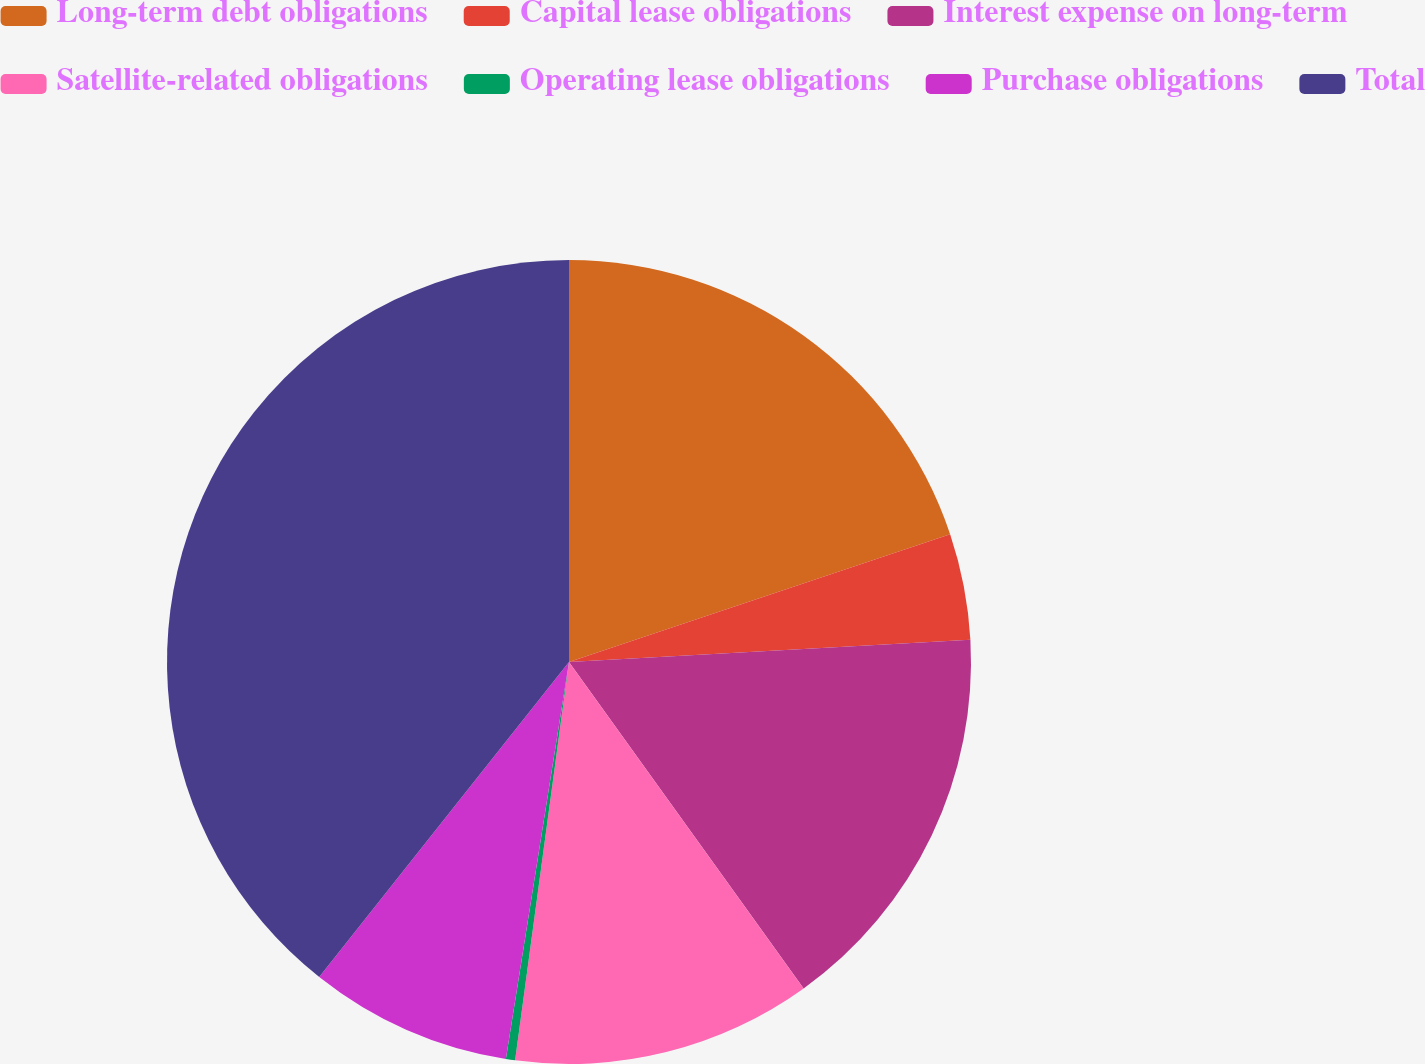<chart> <loc_0><loc_0><loc_500><loc_500><pie_chart><fcel>Long-term debt obligations<fcel>Capital lease obligations<fcel>Interest expense on long-term<fcel>Satellite-related obligations<fcel>Operating lease obligations<fcel>Purchase obligations<fcel>Total<nl><fcel>19.85%<fcel>4.27%<fcel>15.96%<fcel>12.06%<fcel>0.37%<fcel>8.16%<fcel>39.33%<nl></chart> 